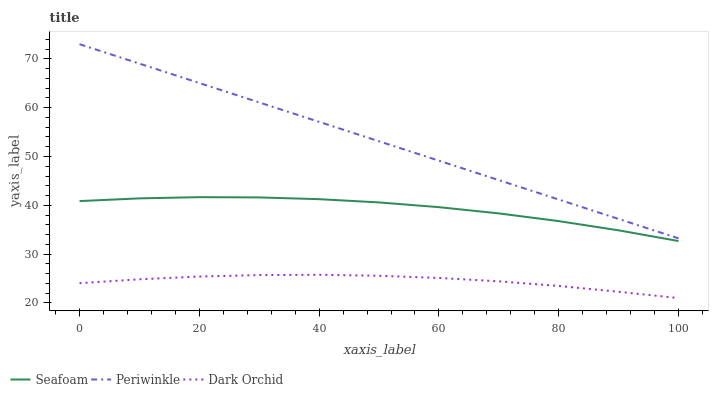Does Dark Orchid have the minimum area under the curve?
Answer yes or no. Yes. Does Periwinkle have the maximum area under the curve?
Answer yes or no. Yes. Does Seafoam have the minimum area under the curve?
Answer yes or no. No. Does Seafoam have the maximum area under the curve?
Answer yes or no. No. Is Periwinkle the smoothest?
Answer yes or no. Yes. Is Seafoam the roughest?
Answer yes or no. Yes. Is Dark Orchid the smoothest?
Answer yes or no. No. Is Dark Orchid the roughest?
Answer yes or no. No. Does Dark Orchid have the lowest value?
Answer yes or no. Yes. Does Seafoam have the lowest value?
Answer yes or no. No. Does Periwinkle have the highest value?
Answer yes or no. Yes. Does Seafoam have the highest value?
Answer yes or no. No. Is Dark Orchid less than Periwinkle?
Answer yes or no. Yes. Is Periwinkle greater than Dark Orchid?
Answer yes or no. Yes. Does Dark Orchid intersect Periwinkle?
Answer yes or no. No. 